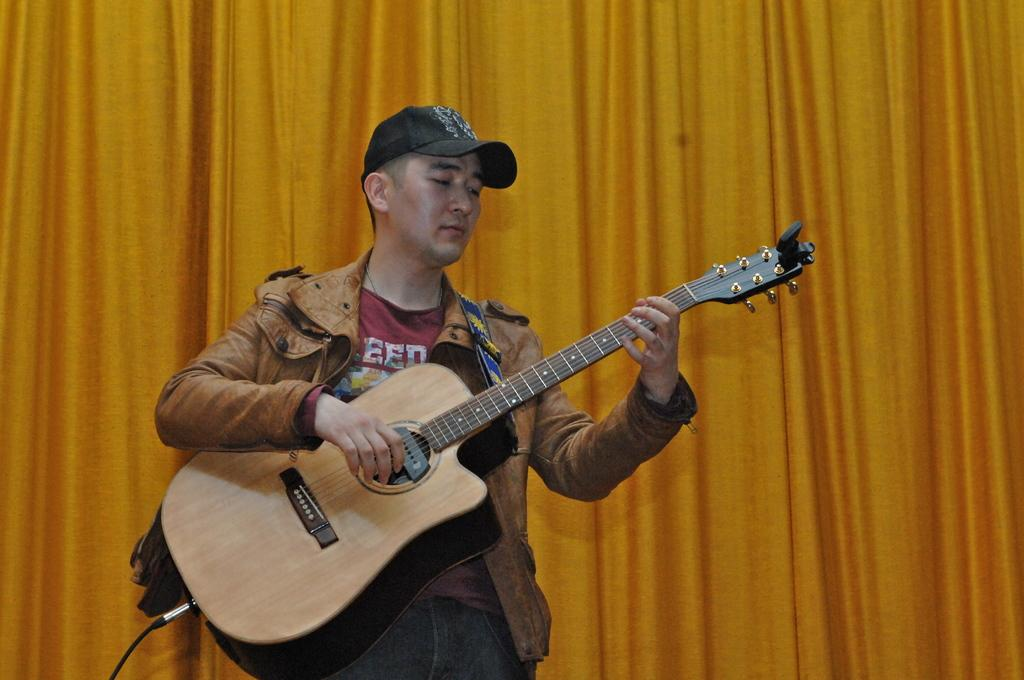Who is the main subject in the image? There is a man in the image. What is the man wearing on his head? The man is wearing a black color cap. What is the man doing in the image? The man is playing a guitar. What color is the curtain in the background of the image? There is a yellow color curtain in the background of the image. Can you see the ocean in the image? There is no ocean visible in the image. 